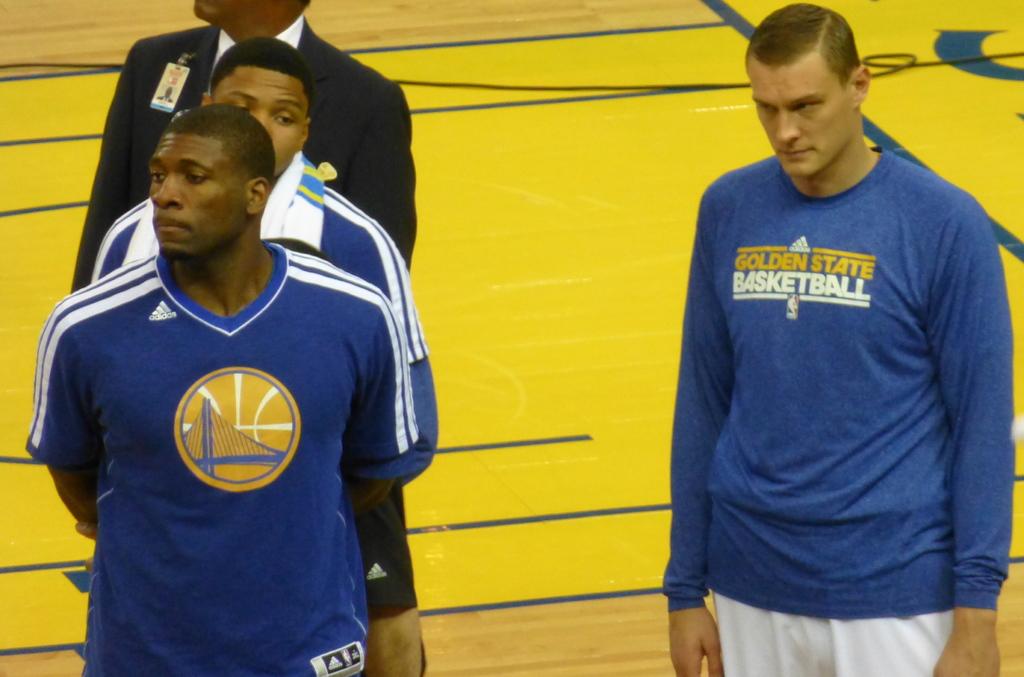What sport do these men play?
Keep it short and to the point. Basketball. 